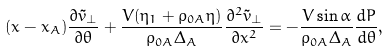Convert formula to latex. <formula><loc_0><loc_0><loc_500><loc_500>( x - x _ { A } ) \frac { \partial \tilde { v } _ { \perp } } { \partial \theta } + \frac { V ( \eta _ { 1 } + \rho _ { 0 A } \eta ) } { \rho _ { 0 A } \Delta _ { A } } \frac { \partial ^ { 2 } \tilde { v } _ { \perp } } { \partial x ^ { 2 } } = - \frac { V \sin \alpha } { \rho _ { 0 A } \Delta _ { A } } \frac { d P } { d \theta } ,</formula> 